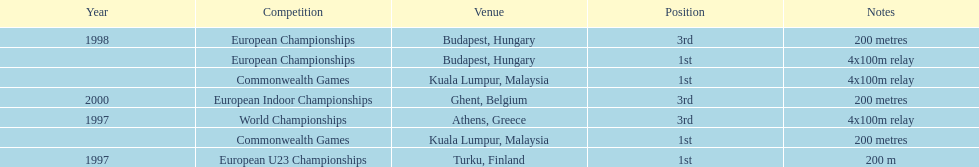List the competitions that have the same relay as world championships from athens, greece. European Championships, Commonwealth Games. 